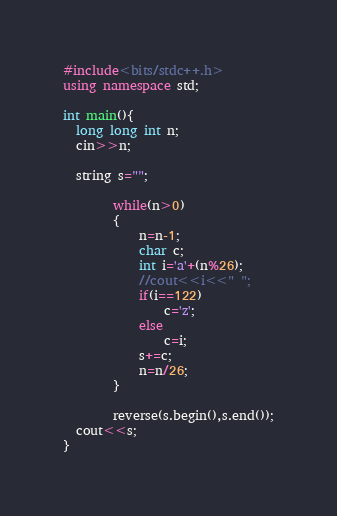<code> <loc_0><loc_0><loc_500><loc_500><_C++_>#include<bits/stdc++.h>
using namespace std;

int main(){
  long long int n;
  cin>>n;
  
  string s="";
        
        while(n>0)
        {
            n=n-1;
            char c;
            int i='a'+(n%26);
            //cout<<i<<" ";
            if(i==122)
                c='z';
            else
                c=i;
            s+=c;
            n=n/26;
        }
        
        reverse(s.begin(),s.end());
  cout<<s;
}</code> 